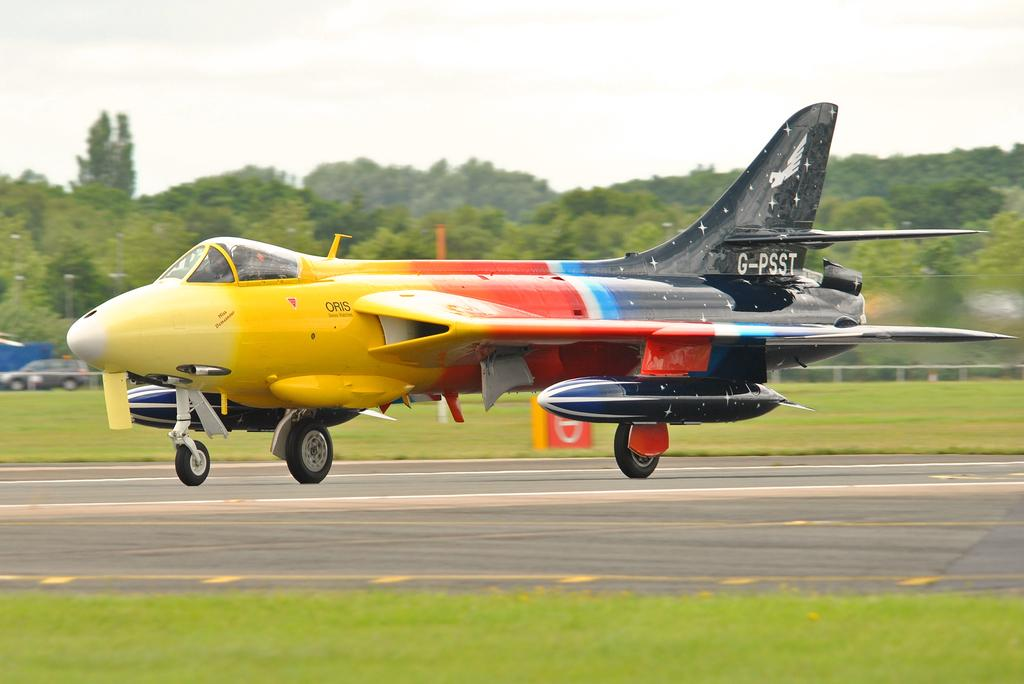<image>
Give a short and clear explanation of the subsequent image. The ORIS company name is visible on the side of a yellow, orange and blue jet. 